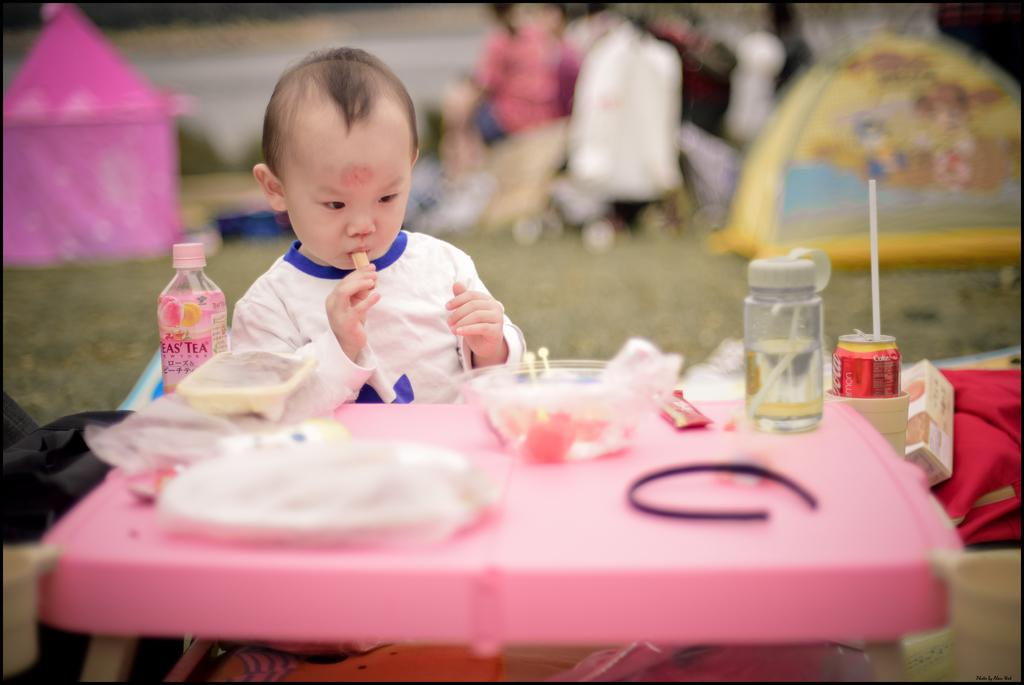Who is the main subject in the image? There is a boy in the image. What is the boy doing in the image? The boy is eating in the image. What is located in front of the boy? There is a table in front of the boy. What items can be seen on the table? There is a bottle, a bowl, and chocolate on the table. What type of riddle is the boy trying to solve in the image? There is no riddle present in the image; the boy is simply eating. How many women are visible in the image? There are no women visible in the image; it features a boy eating. What type of music can be heard playing in the background of the image? There is no music present in the image; it only shows a boy eating at a table with various items. 